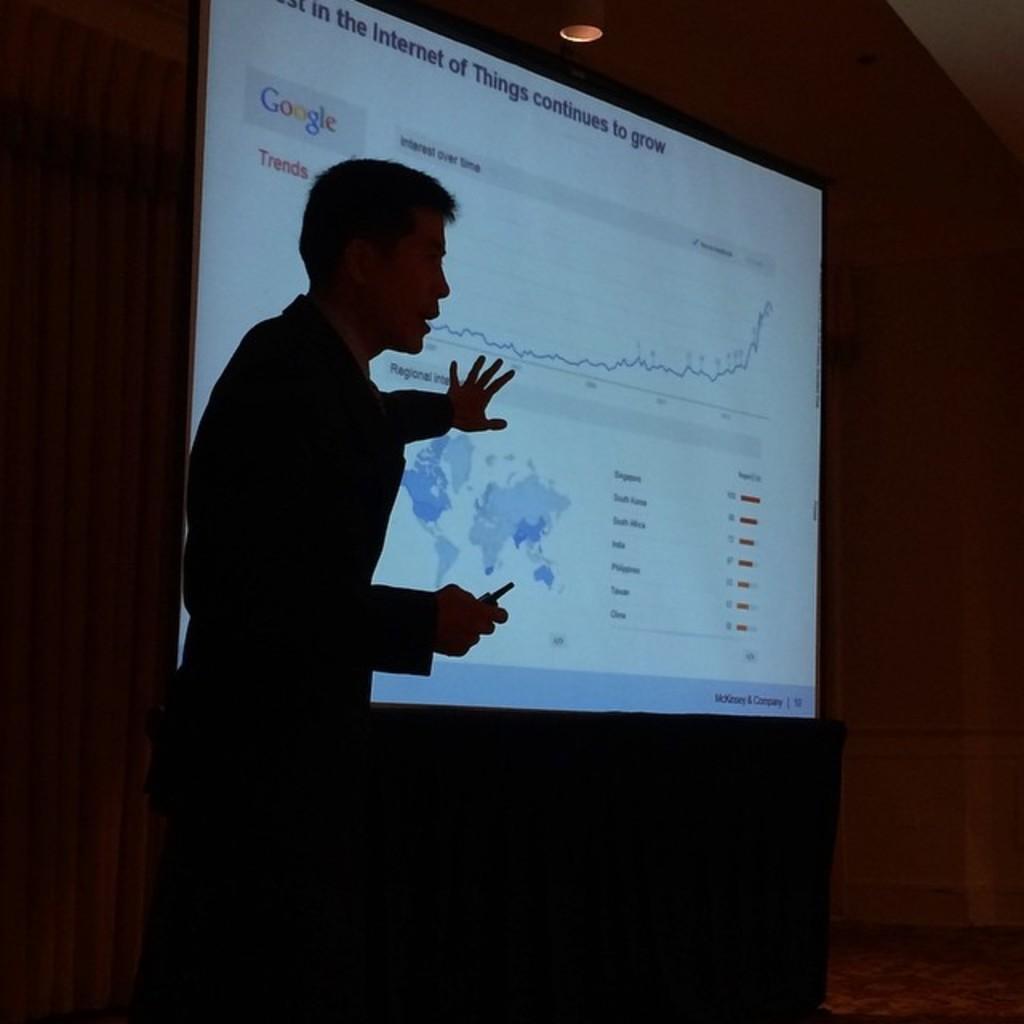How would you summarize this image in a sentence or two? In this image we can see a person standing and holding an object, there is a projector with some text and map, the background looks like the wall. 